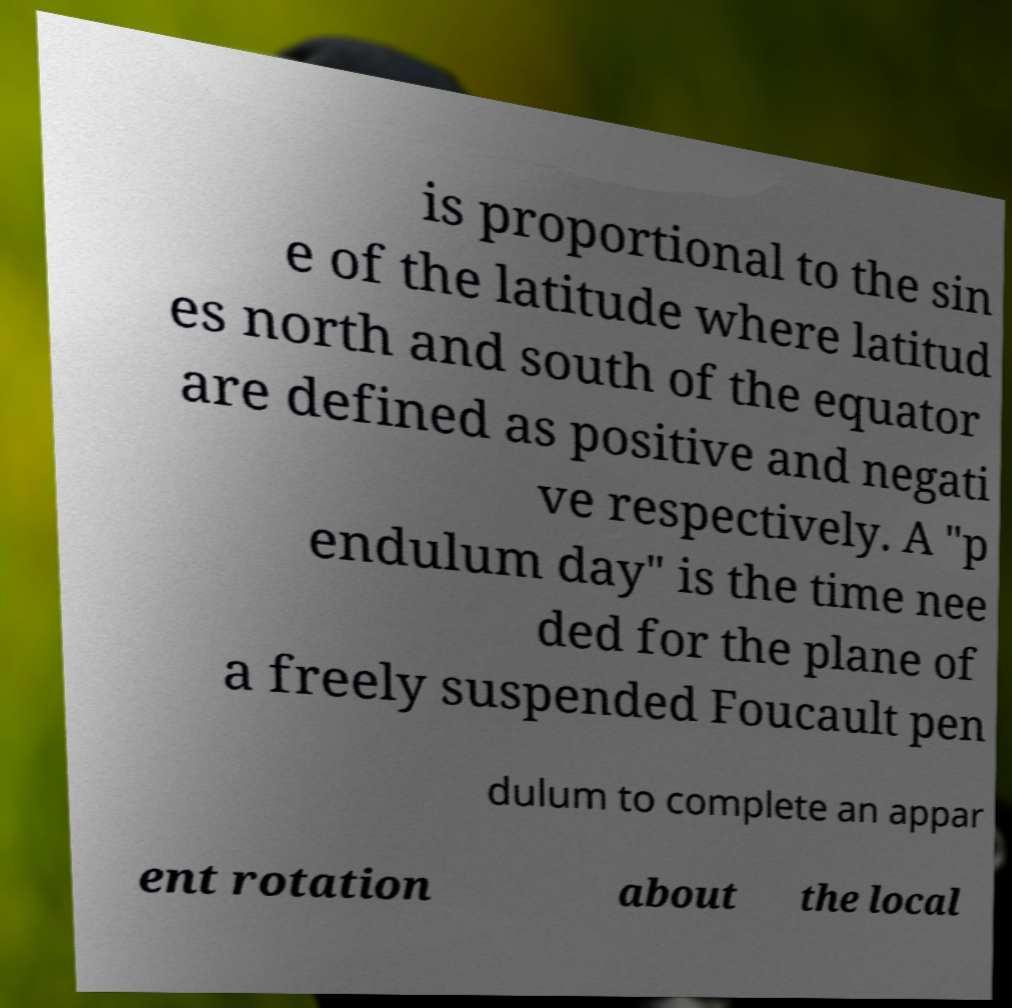Please read and relay the text visible in this image. What does it say? is proportional to the sin e of the latitude where latitud es north and south of the equator are defined as positive and negati ve respectively. A "p endulum day" is the time nee ded for the plane of a freely suspended Foucault pen dulum to complete an appar ent rotation about the local 